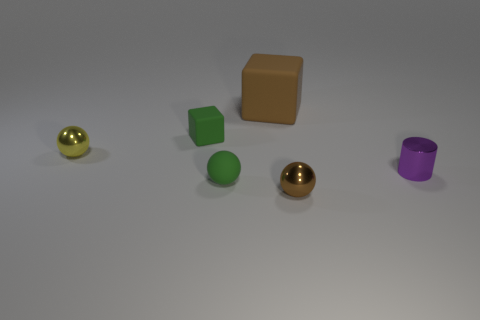There is a yellow thing that is the same size as the purple cylinder; what is its material?
Your response must be concise. Metal. There is a sphere that is the same color as the large matte cube; what is it made of?
Your response must be concise. Metal. The big matte thing has what color?
Keep it short and to the point. Brown. There is a green matte object in front of the tiny matte cube; is its shape the same as the yellow metallic object?
Offer a terse response. Yes. How many things are either brown metal things or tiny balls that are on the left side of the small cube?
Give a very brief answer. 2. Are the brown sphere in front of the brown rubber thing and the purple cylinder made of the same material?
Your answer should be very brief. Yes. Is there anything else that has the same size as the brown metal thing?
Provide a short and direct response. Yes. What material is the ball that is on the right side of the small green rubber thing that is in front of the purple metal object made of?
Provide a succinct answer. Metal. Are there more yellow things that are right of the big object than small matte cubes left of the small block?
Ensure brevity in your answer.  No. The green ball is what size?
Make the answer very short. Small. 